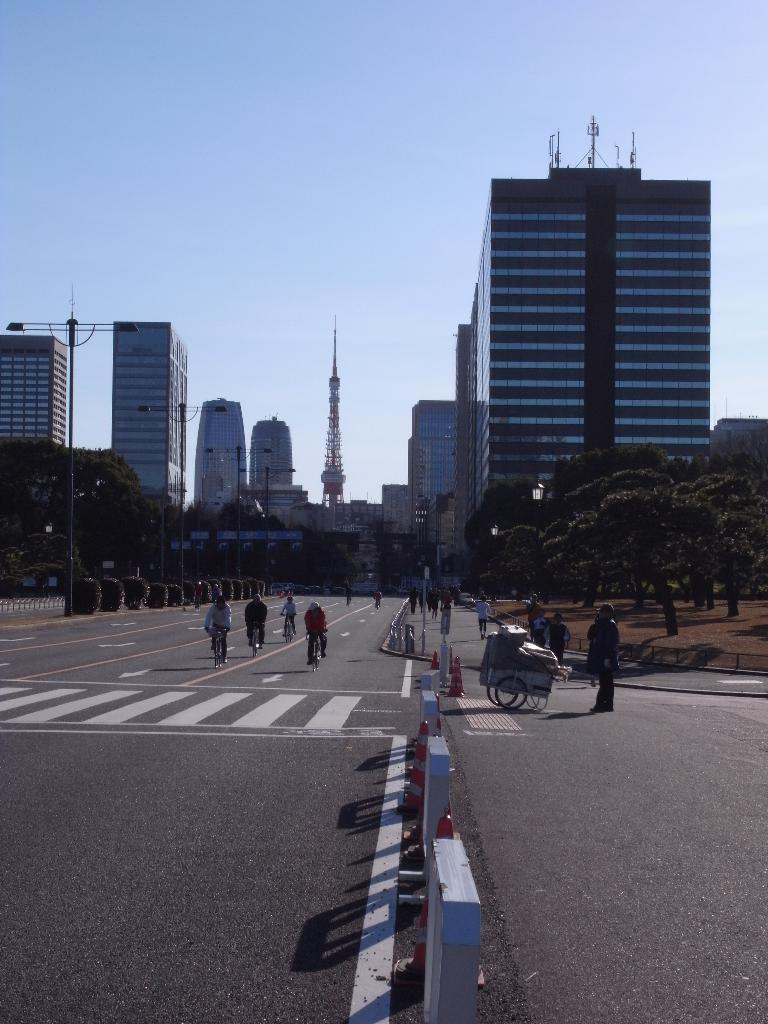What are the persons in the image doing? The persons in the image are riding bicycles on the road. What can be seen in the background of the image? There are trees and buildings in the background of the image. How many beggars are present in the image? There are no beggars present in the image; it features persons riding bicycles on the road. What type of discovery can be seen in the image? There is no discovery present in the image; it features persons riding bicycles on the road and the background with trees and buildings. 